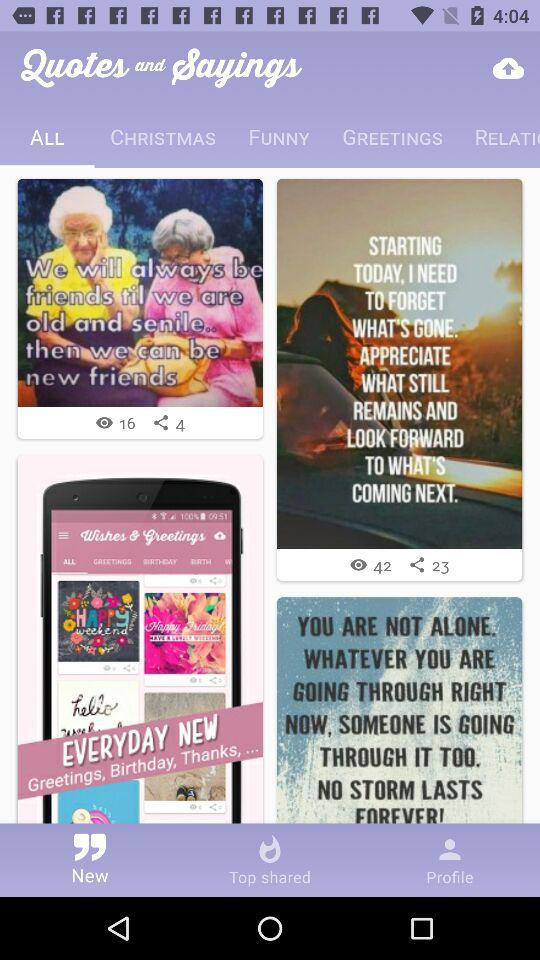How many times has the quote "We will always be friends" been shared? The quote "We will always be friends" has been shared 4 times. 